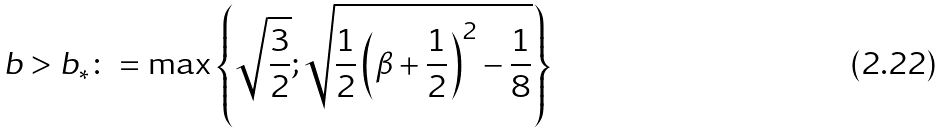Convert formula to latex. <formula><loc_0><loc_0><loc_500><loc_500>b > b _ { \ast } \colon = \max \left \{ \sqrt { \frac { 3 } { 2 } } ; \sqrt { \frac { 1 } { 2 } \left ( \beta + \frac { 1 } { 2 } \right ) ^ { 2 } - \frac { 1 } { 8 } } \right \}</formula> 